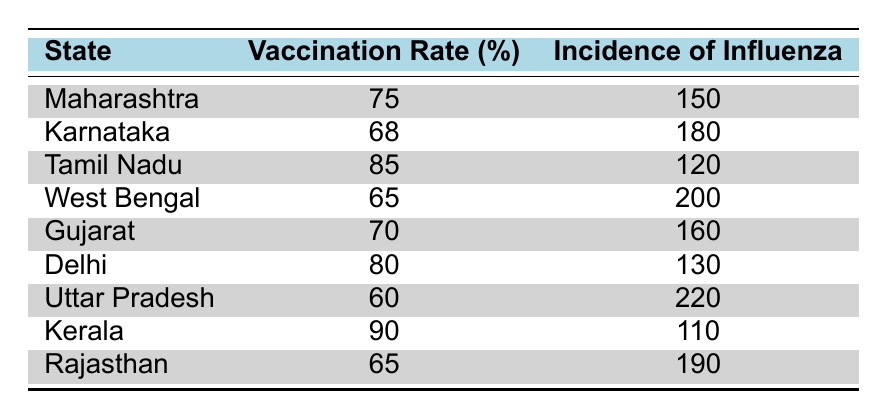What is the vaccination rate in Kerala? The table lists the state of Kerala and provides the vaccination rate as 90%.
Answer: 90 Which state has the highest incidence of influenza? From the table, Uttar Pradesh shows the highest incidence of influenza at 220 cases.
Answer: Uttar Pradesh What is the difference in incidence of influenza between the states of Maharashtra and Tamil Nadu? The incidence of influenza in Maharashtra is 150 and in Tamil Nadu is 120. The difference is 150 - 120 = 30.
Answer: 30 Is the vaccination rate in Karnataka higher than that in Gujarat? The vaccination rate in Karnataka is 68%, while in Gujarat, it is 70%. Since 68% is less than 70%, the statement is false.
Answer: No What is the average vaccination rate across all states listed? Summing the vaccination rates: 75 + 68 + 85 + 65 + 70 + 80 + 60 + 90 + 65 =  688. There are 9 data points, so the average vaccination rate is 688 / 9 ≈ 76.44.
Answer: 76.44 Which state has the lowest vaccination rate, and what is its incidence of influenza? The lowest vaccination rate is in Uttar Pradesh at 60%, and its incidence of influenza is 220.
Answer: Uttar Pradesh, 220 Is it true that the states with higher vaccination rates tend to have lower incidences of influenza? By examining the table, it is evident that states with higher vaccination rates, like Kerala and Tamil Nadu, have lower incidence levels than those with lower rates like Uttar Pradesh and West Bengal. Therefore, the statement is true.
Answer: Yes What is the highest vaccination rate among the states listed? The highest vaccination rate in the table is found in Kerala at 90%.
Answer: 90 How many states have an incidence of influenza greater than 180? According to the table, the states with an incidence greater than 180 are Karnataka, West Bengal, Uttar Pradesh, and Rajasthan. That makes a total of 4 states.
Answer: 4 